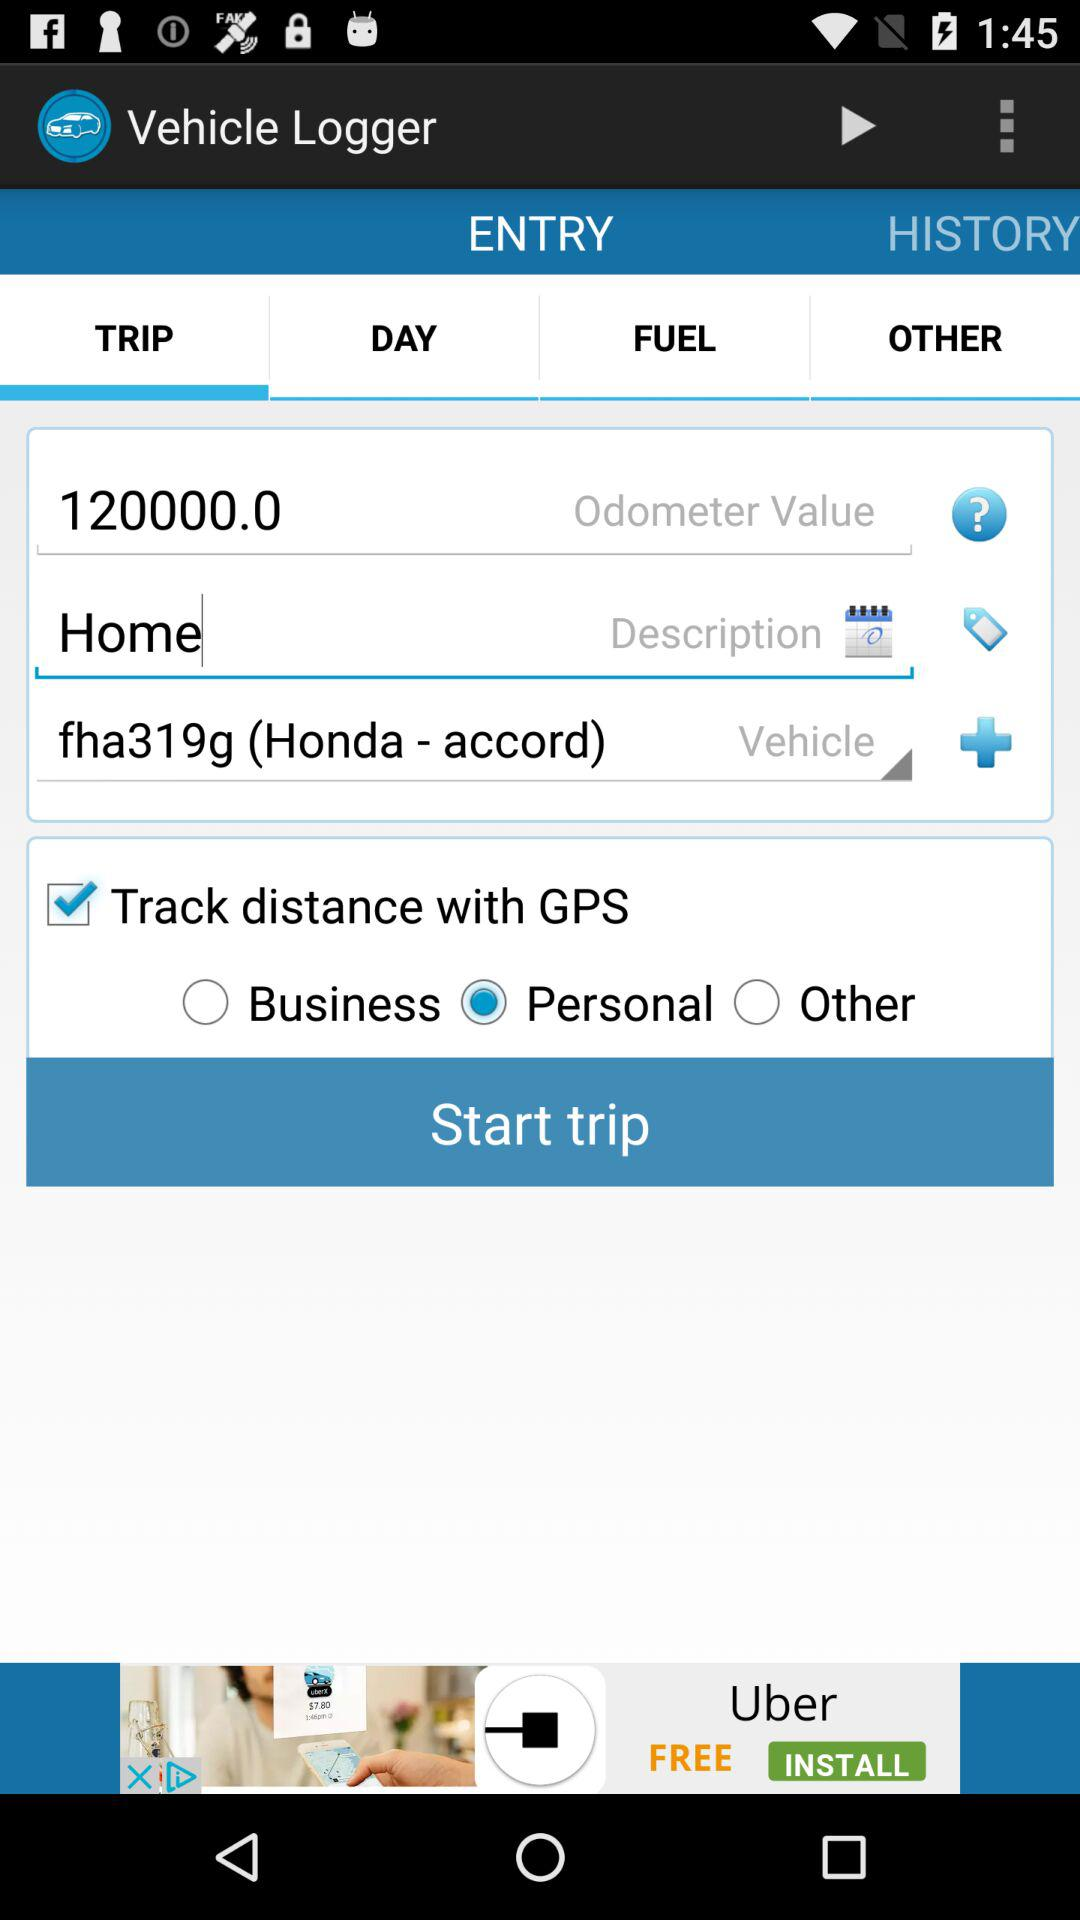On which tab are we right now? You are on "ENTRY" and "TRIP" tabs. 